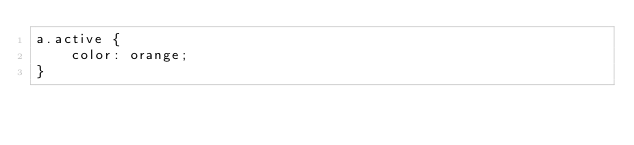<code> <loc_0><loc_0><loc_500><loc_500><_CSS_>a.active {
    color: orange;
}</code> 